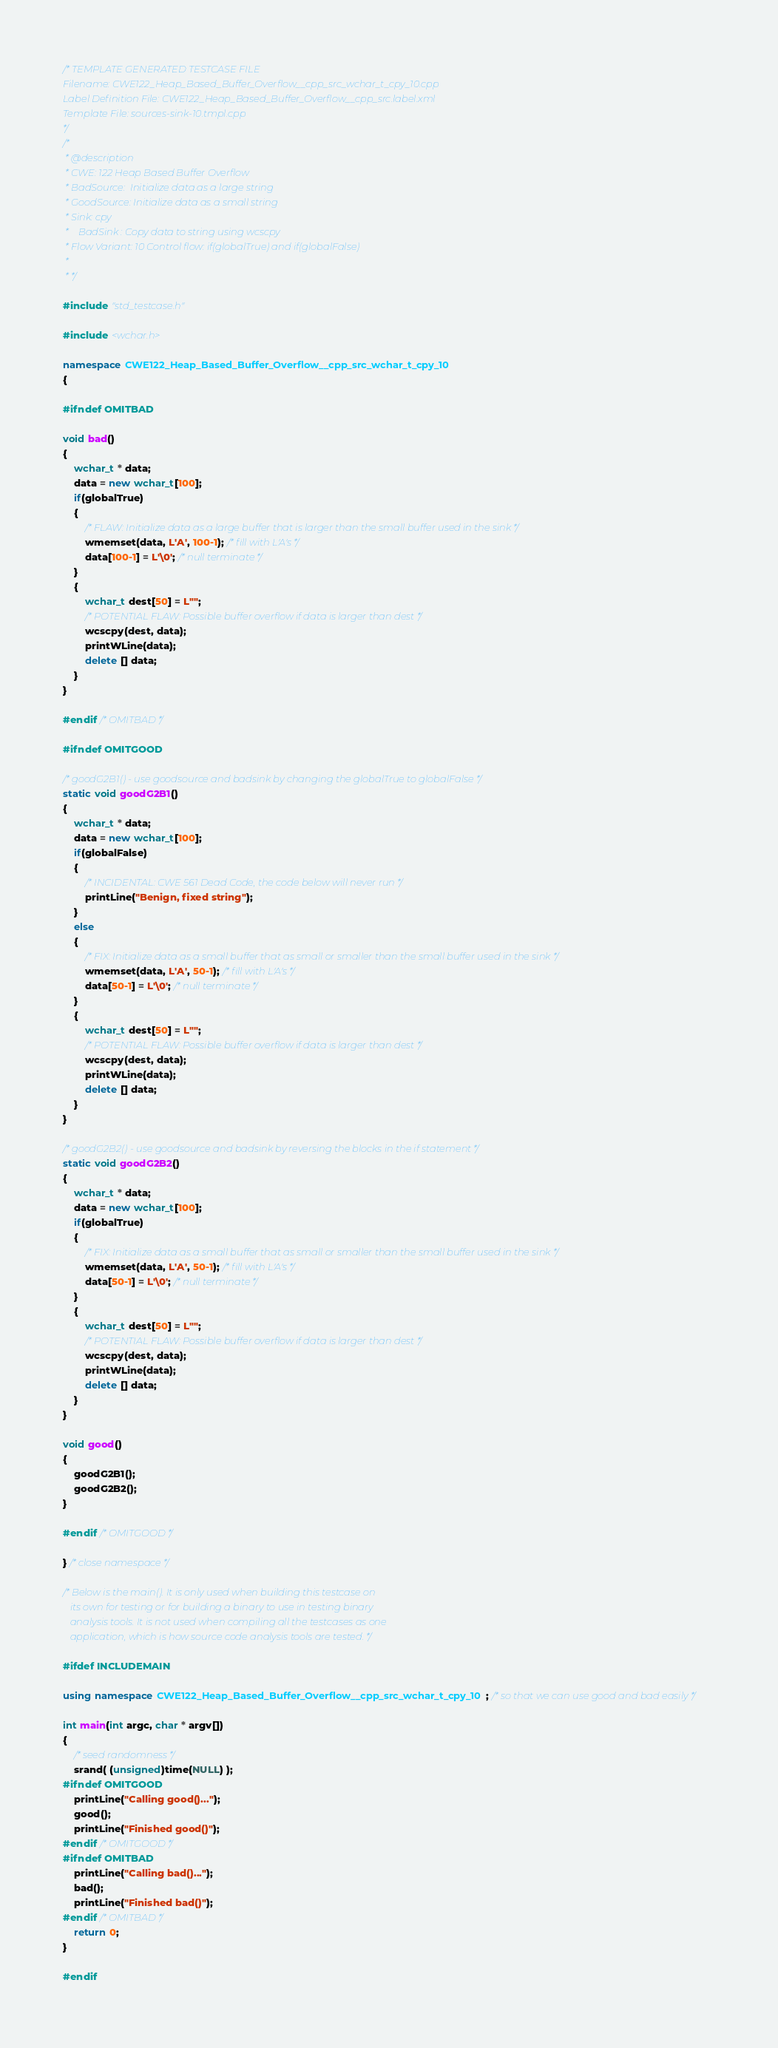<code> <loc_0><loc_0><loc_500><loc_500><_C++_>/* TEMPLATE GENERATED TESTCASE FILE
Filename: CWE122_Heap_Based_Buffer_Overflow__cpp_src_wchar_t_cpy_10.cpp
Label Definition File: CWE122_Heap_Based_Buffer_Overflow__cpp_src.label.xml
Template File: sources-sink-10.tmpl.cpp
*/
/*
 * @description
 * CWE: 122 Heap Based Buffer Overflow
 * BadSource:  Initialize data as a large string
 * GoodSource: Initialize data as a small string
 * Sink: cpy
 *    BadSink : Copy data to string using wcscpy
 * Flow Variant: 10 Control flow: if(globalTrue) and if(globalFalse)
 *
 * */

#include "std_testcase.h"

#include <wchar.h>

namespace CWE122_Heap_Based_Buffer_Overflow__cpp_src_wchar_t_cpy_10
{

#ifndef OMITBAD

void bad()
{
    wchar_t * data;
    data = new wchar_t[100];
    if(globalTrue)
    {
        /* FLAW: Initialize data as a large buffer that is larger than the small buffer used in the sink */
        wmemset(data, L'A', 100-1); /* fill with L'A's */
        data[100-1] = L'\0'; /* null terminate */
    }
    {
        wchar_t dest[50] = L"";
        /* POTENTIAL FLAW: Possible buffer overflow if data is larger than dest */
        wcscpy(dest, data);
        printWLine(data);
        delete [] data;
    }
}

#endif /* OMITBAD */

#ifndef OMITGOOD

/* goodG2B1() - use goodsource and badsink by changing the globalTrue to globalFalse */
static void goodG2B1()
{
    wchar_t * data;
    data = new wchar_t[100];
    if(globalFalse)
    {
        /* INCIDENTAL: CWE 561 Dead Code, the code below will never run */
        printLine("Benign, fixed string");
    }
    else
    {
        /* FIX: Initialize data as a small buffer that as small or smaller than the small buffer used in the sink */
        wmemset(data, L'A', 50-1); /* fill with L'A's */
        data[50-1] = L'\0'; /* null terminate */
    }
    {
        wchar_t dest[50] = L"";
        /* POTENTIAL FLAW: Possible buffer overflow if data is larger than dest */
        wcscpy(dest, data);
        printWLine(data);
        delete [] data;
    }
}

/* goodG2B2() - use goodsource and badsink by reversing the blocks in the if statement */
static void goodG2B2()
{
    wchar_t * data;
    data = new wchar_t[100];
    if(globalTrue)
    {
        /* FIX: Initialize data as a small buffer that as small or smaller than the small buffer used in the sink */
        wmemset(data, L'A', 50-1); /* fill with L'A's */
        data[50-1] = L'\0'; /* null terminate */
    }
    {
        wchar_t dest[50] = L"";
        /* POTENTIAL FLAW: Possible buffer overflow if data is larger than dest */
        wcscpy(dest, data);
        printWLine(data);
        delete [] data;
    }
}

void good()
{
    goodG2B1();
    goodG2B2();
}

#endif /* OMITGOOD */

} /* close namespace */

/* Below is the main(). It is only used when building this testcase on
   its own for testing or for building a binary to use in testing binary
   analysis tools. It is not used when compiling all the testcases as one
   application, which is how source code analysis tools are tested. */

#ifdef INCLUDEMAIN

using namespace CWE122_Heap_Based_Buffer_Overflow__cpp_src_wchar_t_cpy_10; /* so that we can use good and bad easily */

int main(int argc, char * argv[])
{
    /* seed randomness */
    srand( (unsigned)time(NULL) );
#ifndef OMITGOOD
    printLine("Calling good()...");
    good();
    printLine("Finished good()");
#endif /* OMITGOOD */
#ifndef OMITBAD
    printLine("Calling bad()...");
    bad();
    printLine("Finished bad()");
#endif /* OMITBAD */
    return 0;
}

#endif
</code> 